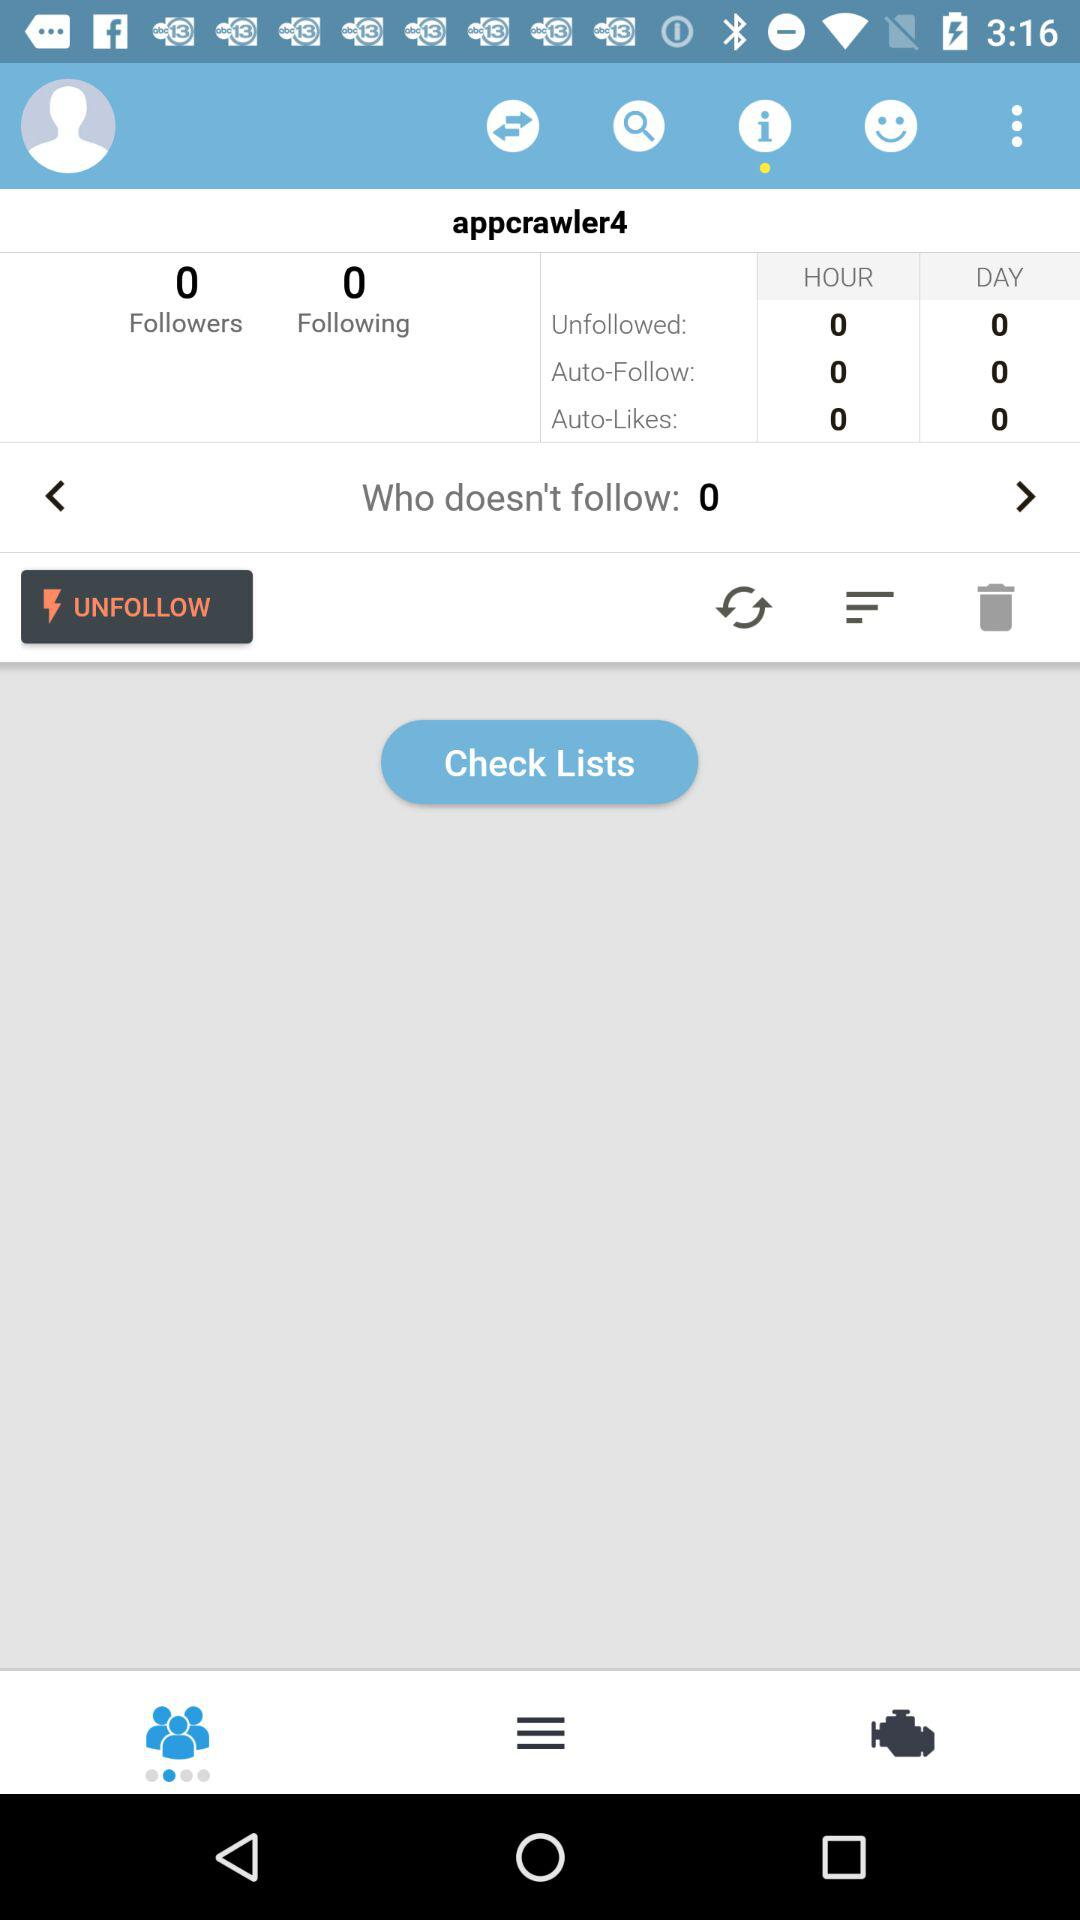How many people unfollowed in an hour? There are 0 people who unfollowed in an hour. 